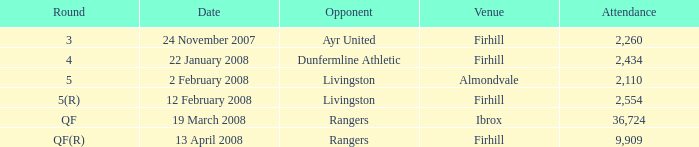What is the average attendance at a game held at Firhill for the 5(r) round? 2554.0. 